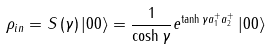Convert formula to latex. <formula><loc_0><loc_0><loc_500><loc_500>\rho _ { i n } = S \left ( \gamma \right ) \left | 0 0 \right \rangle = \frac { 1 } { \cosh \gamma } e ^ { \tanh \gamma a _ { 1 } ^ { + } a _ { 2 } ^ { + } } \left | 0 0 \right \rangle</formula> 